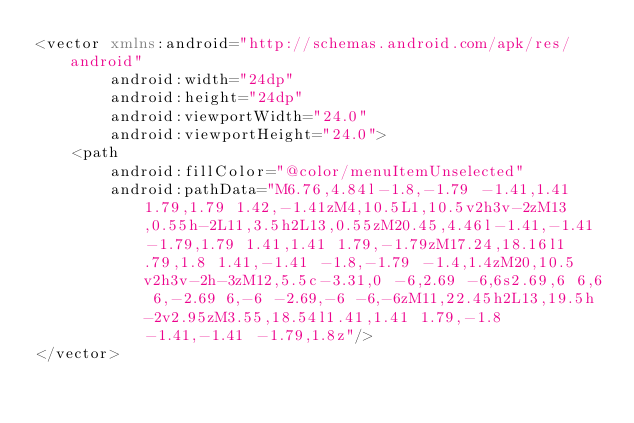Convert code to text. <code><loc_0><loc_0><loc_500><loc_500><_XML_><vector xmlns:android="http://schemas.android.com/apk/res/android"
        android:width="24dp"
        android:height="24dp"
        android:viewportWidth="24.0"
        android:viewportHeight="24.0">
    <path
        android:fillColor="@color/menuItemUnselected"
        android:pathData="M6.76,4.84l-1.8,-1.79 -1.41,1.41 1.79,1.79 1.42,-1.41zM4,10.5L1,10.5v2h3v-2zM13,0.55h-2L11,3.5h2L13,0.55zM20.45,4.46l-1.41,-1.41 -1.79,1.79 1.41,1.41 1.79,-1.79zM17.24,18.16l1.79,1.8 1.41,-1.41 -1.8,-1.79 -1.4,1.4zM20,10.5v2h3v-2h-3zM12,5.5c-3.31,0 -6,2.69 -6,6s2.69,6 6,6 6,-2.69 6,-6 -2.69,-6 -6,-6zM11,22.45h2L13,19.5h-2v2.95zM3.55,18.54l1.41,1.41 1.79,-1.8 -1.41,-1.41 -1.79,1.8z"/>
</vector>
</code> 